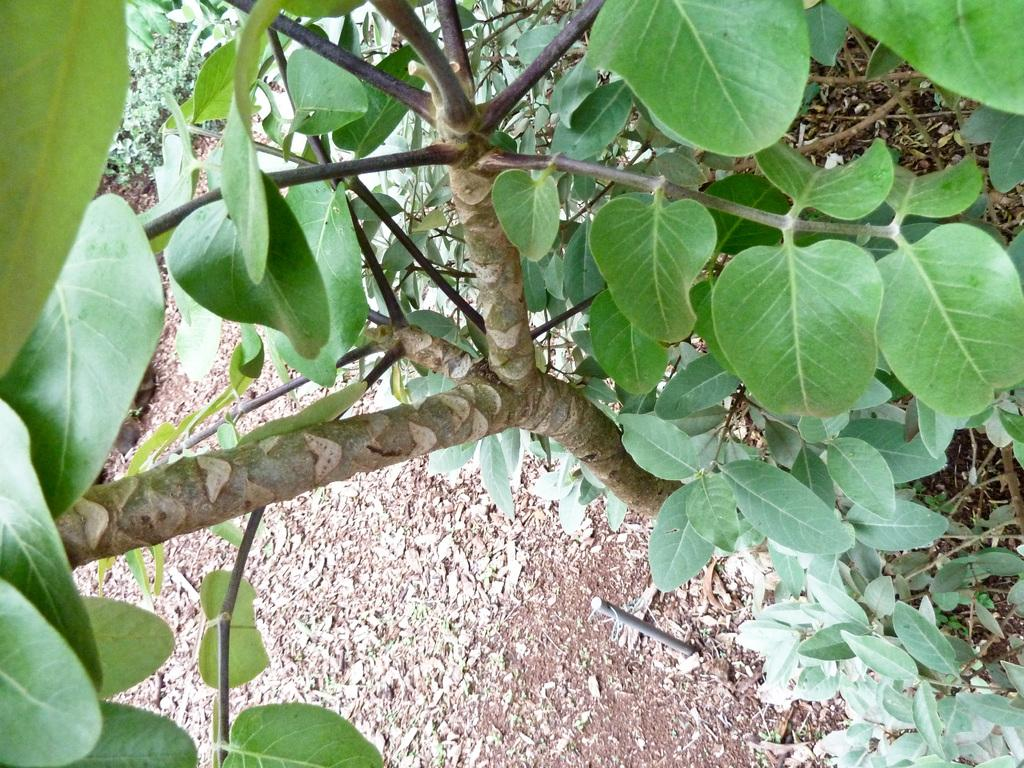What type of vegetation is present in the image? There are trees and plants in the image. What is the color of the trees and plants in the image? The trees and plants are green in color. What can be seen on the ground in the image? There are dried leaves on the ground in the image. What type of hat is the tree wearing in the image? There are no hats present in the image, as trees do not wear hats. 